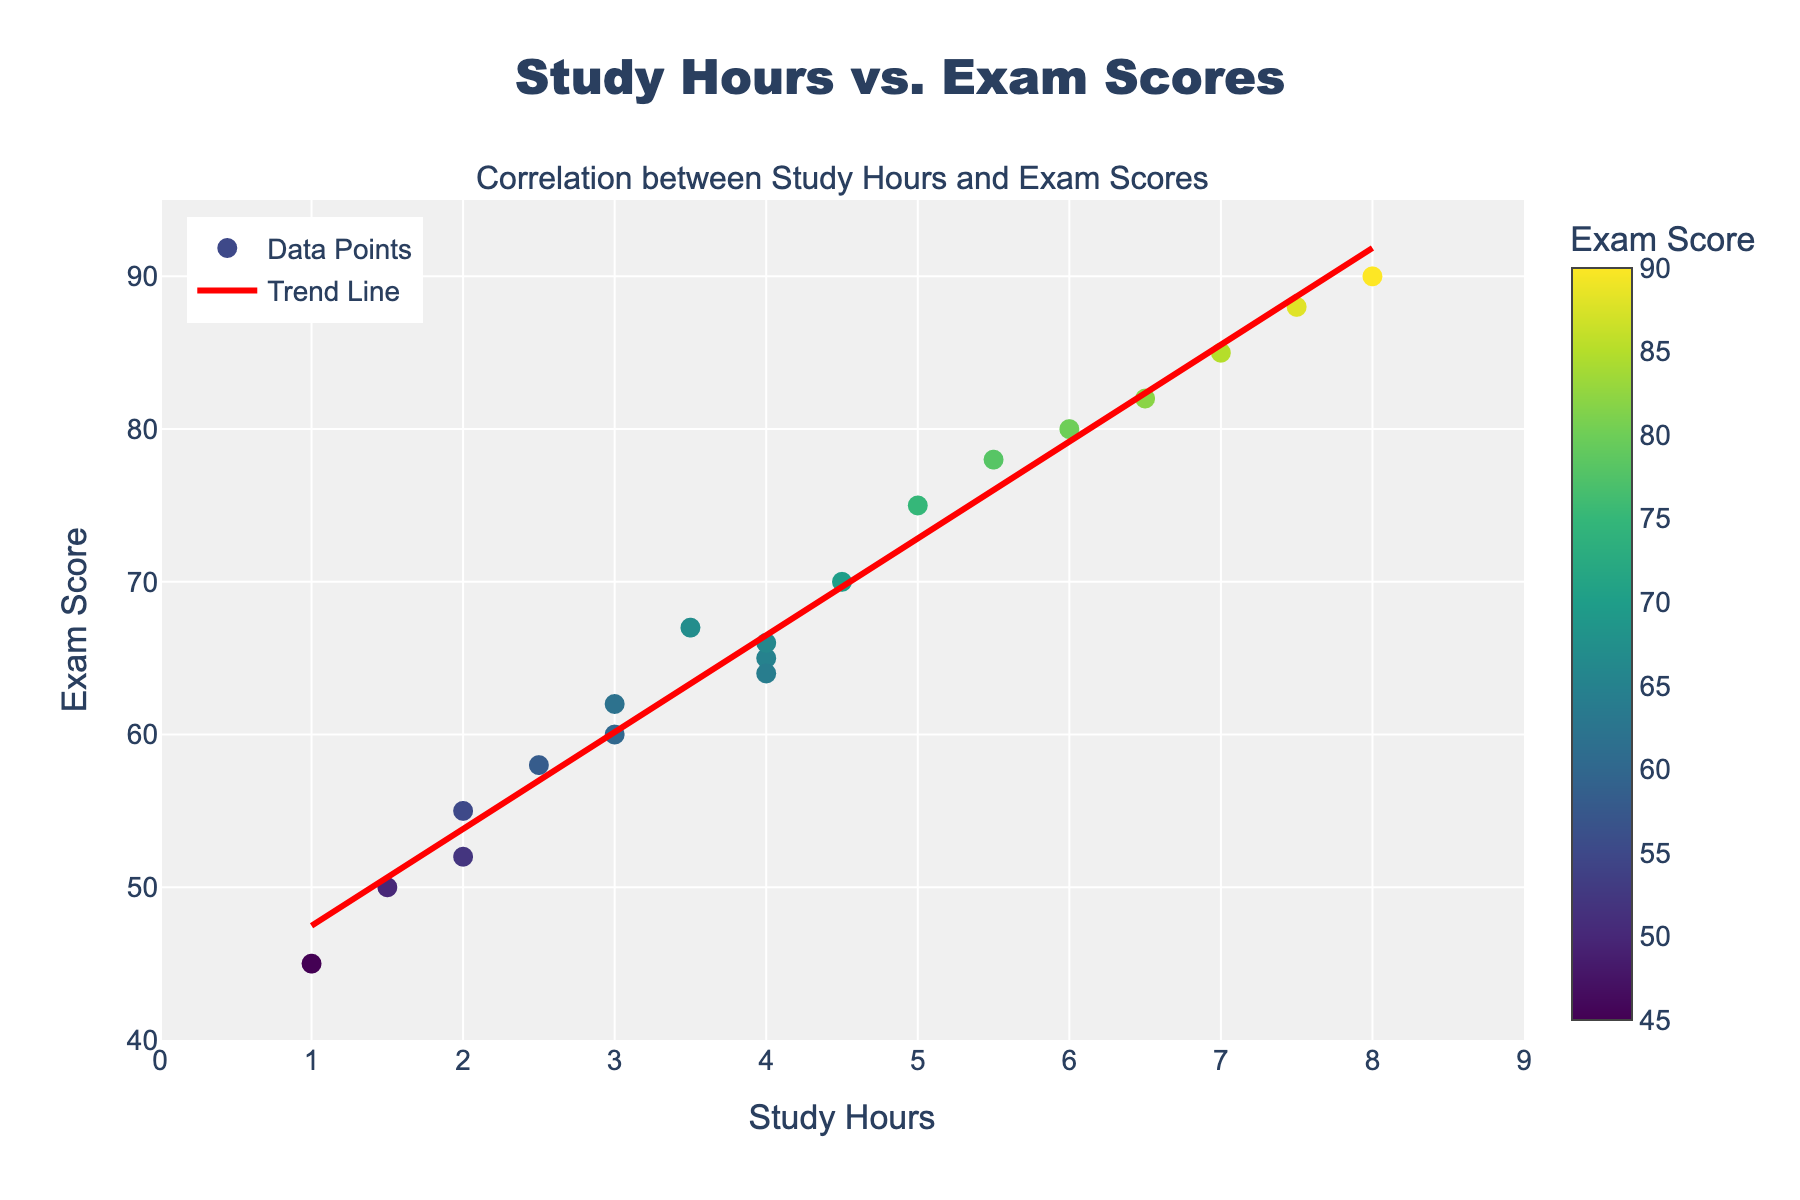What is the title of the figure? The title is usually located at the top of the figure. In this case, it reads "Study Hours vs. Exam Scores."
Answer: Study Hours vs. Exam Scores What do the x-axis and y-axis represent? The x-axis represents Study Hours, as indicated at the bottom of the graph. The y-axis represents Exam Score, as indicated on the left side of the graph.
Answer: Study Hours (x-axis) and Exam Score (y-axis) How many data points are there in the scatter plot? The data points can be counted by looking at the individual markers on the scatter plot. There are a total of 20 data points in the plot.
Answer: 20 What is the general trend indicated by the trend line? The trend line shows a general upward slope. This indicates that as the number of study hours increases, the exam scores tend to increase as well.
Answer: As study hours increase, exam scores increase Which data point has the highest exam score, and what are its study hours? Locate the highest point on the y-axis and check its corresponding x-axis value. The highest exam score is 90, with corresponding study hours of 8 hours.
Answer: 8 study hours, 90 exam score What is the exam score when the study hours are 1 hour? Find the marker at 1 on the x-axis and check its corresponding y-axis value. The exam score is 45 when the study hours are 1 hour.
Answer: 45 What is the range of study hours shown in the figure? To find the range, locate the minimum and maximum x-axis values. The study hours range from 1 to 8 hours.
Answer: 1 to 8 hours If a student studies for 3 hours, what is the expected exam score according to the trend line? Find 3 on the x-axis and check the trend line's corresponding y-axis value. The trend line indicates an expected exam score of around 60-62 for 3 hours of study.
Answer: Around 60-62 What is the difference in exam score between studying for 5 hours and 2 hours? Find the exam scores for 5 hours and 2 hours on the scatter plot. The scores are 75 and 52 respectively. The difference is 75 - 52 = 23.
Answer: 23 Which data point deviates the most from the trend line? Compare all data points to the trend line and identify the one farthest away. The data point for 1 hour of study and an exam score of 45 deviates significantly from the trend line.
Answer: 1 hour, 45 exam score 